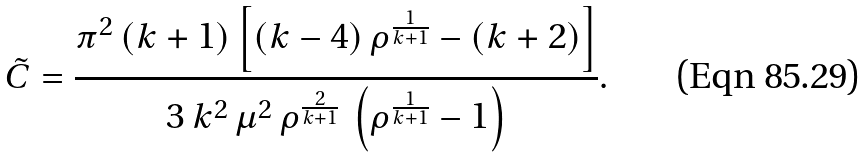<formula> <loc_0><loc_0><loc_500><loc_500>\tilde { C } = \frac { \pi ^ { 2 } \, ( k + 1 ) \left [ ( k - 4 ) \, \rho ^ { \frac { 1 } { k + 1 } } - ( k + 2 ) \right ] } { 3 \, k ^ { 2 } \, \mu ^ { 2 } \, \rho ^ { \frac { 2 } { k + 1 } } \, \left ( \rho ^ { \frac { 1 } { k + 1 } } - 1 \right ) } .</formula> 